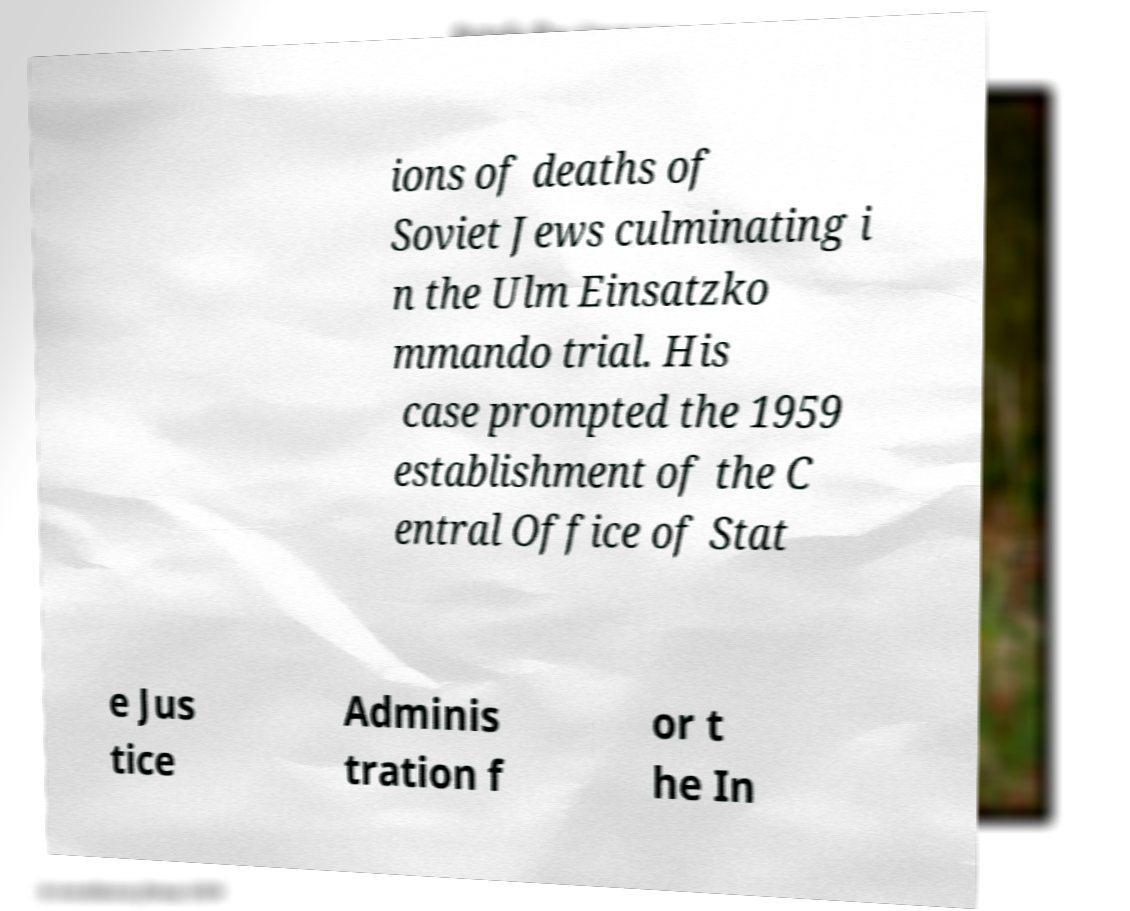Could you extract and type out the text from this image? ions of deaths of Soviet Jews culminating i n the Ulm Einsatzko mmando trial. His case prompted the 1959 establishment of the C entral Office of Stat e Jus tice Adminis tration f or t he In 